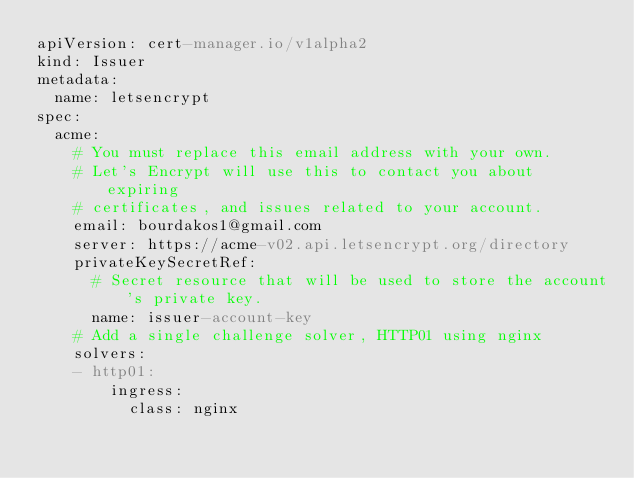Convert code to text. <code><loc_0><loc_0><loc_500><loc_500><_YAML_>apiVersion: cert-manager.io/v1alpha2
kind: Issuer
metadata:
  name: letsencrypt
spec:
  acme:
    # You must replace this email address with your own.
    # Let's Encrypt will use this to contact you about expiring
    # certificates, and issues related to your account.
    email: bourdakos1@gmail.com
    server: https://acme-v02.api.letsencrypt.org/directory
    privateKeySecretRef:
      # Secret resource that will be used to store the account's private key.
      name: issuer-account-key
    # Add a single challenge solver, HTTP01 using nginx
    solvers:
    - http01:
        ingress:
          class: nginx</code> 